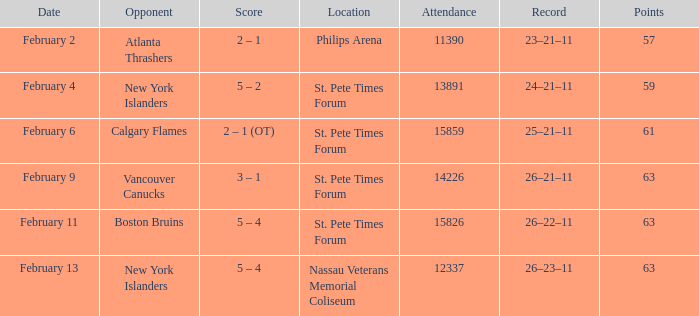Can you provide the scores from february 9? 3 – 1. 